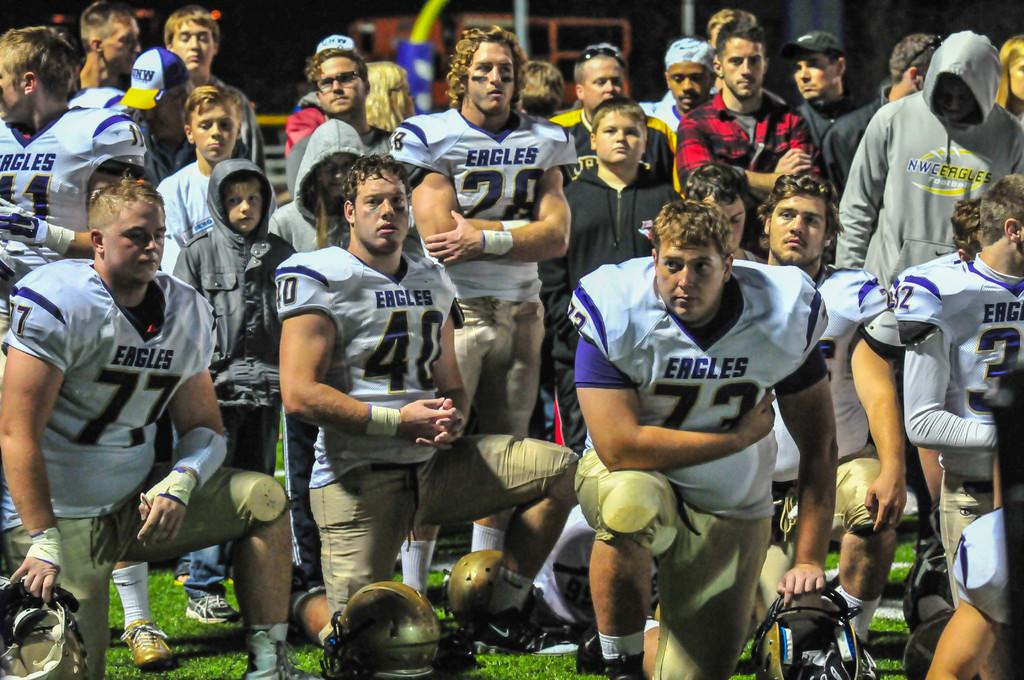What can be seen in the foreground of the image? There is a group of people standing in the front of the image. What type of surface is visible beneath the people's feet? There is grass visible in the image. What protective gear is present in the image? There are helmets present in the image. What can be seen in the background of the image? There is a building in the background of the image. What color is the silver veil worn by the people in the image? There is no silver veil present in the image; the people are wearing helmets. How many feet are visible in the image? The number of feet visible in the image cannot be determined from the provided facts, as the focus is on the group of people standing in the front of the image. 